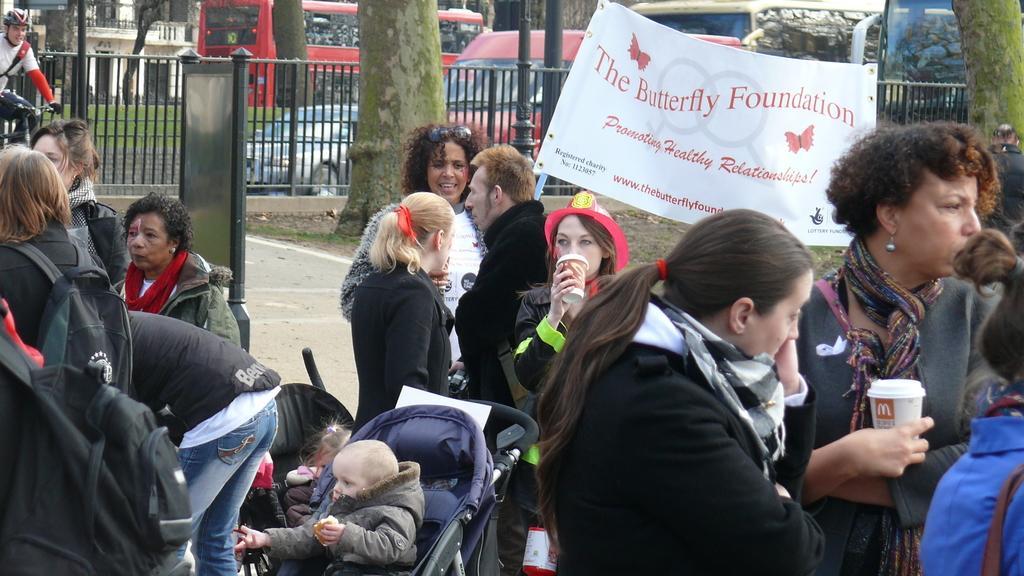In one or two sentences, can you explain what this image depicts? In this picture I can observe some people standing on the land. Most of them are women. I can observe a kid in the stroller. There is a white color poster on the right side. I can observe some text on the poster. In the background there is a railing. I can observe some vehicles on the road. There is a building on the top left side. 